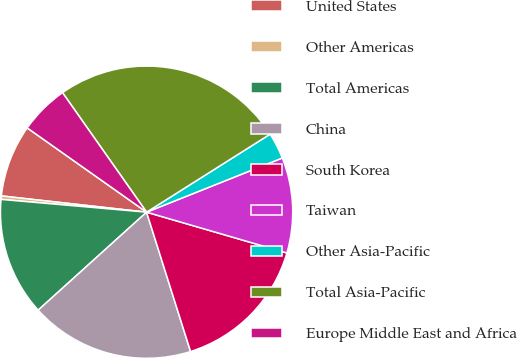Convert chart to OTSL. <chart><loc_0><loc_0><loc_500><loc_500><pie_chart><fcel>United States<fcel>Other Americas<fcel>Total Americas<fcel>China<fcel>South Korea<fcel>Taiwan<fcel>Other Asia-Pacific<fcel>Total Asia-Pacific<fcel>Europe Middle East and Africa<nl><fcel>8.01%<fcel>0.38%<fcel>13.09%<fcel>18.17%<fcel>15.63%<fcel>10.55%<fcel>2.92%<fcel>25.79%<fcel>5.46%<nl></chart> 